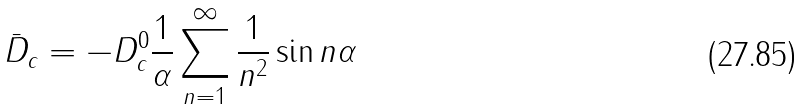<formula> <loc_0><loc_0><loc_500><loc_500>\bar { D } _ { c } = - D _ { c } ^ { 0 } \frac { 1 } { \alpha } \sum _ { n = 1 } ^ { \infty } \frac { 1 } { n ^ { 2 } } \sin n \alpha</formula> 